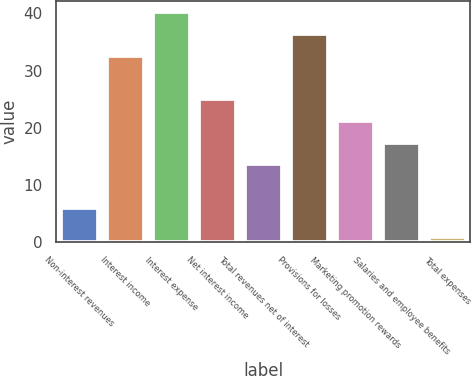Convert chart. <chart><loc_0><loc_0><loc_500><loc_500><bar_chart><fcel>Non-interest revenues<fcel>Interest income<fcel>Interest expense<fcel>Net interest income<fcel>Total revenues net of interest<fcel>Provisions for losses<fcel>Marketing promotion rewards<fcel>Salaries and employee benefits<fcel>Total expenses<nl><fcel>6<fcel>32.6<fcel>40.2<fcel>25<fcel>13.6<fcel>36.4<fcel>21.2<fcel>17.4<fcel>1<nl></chart> 